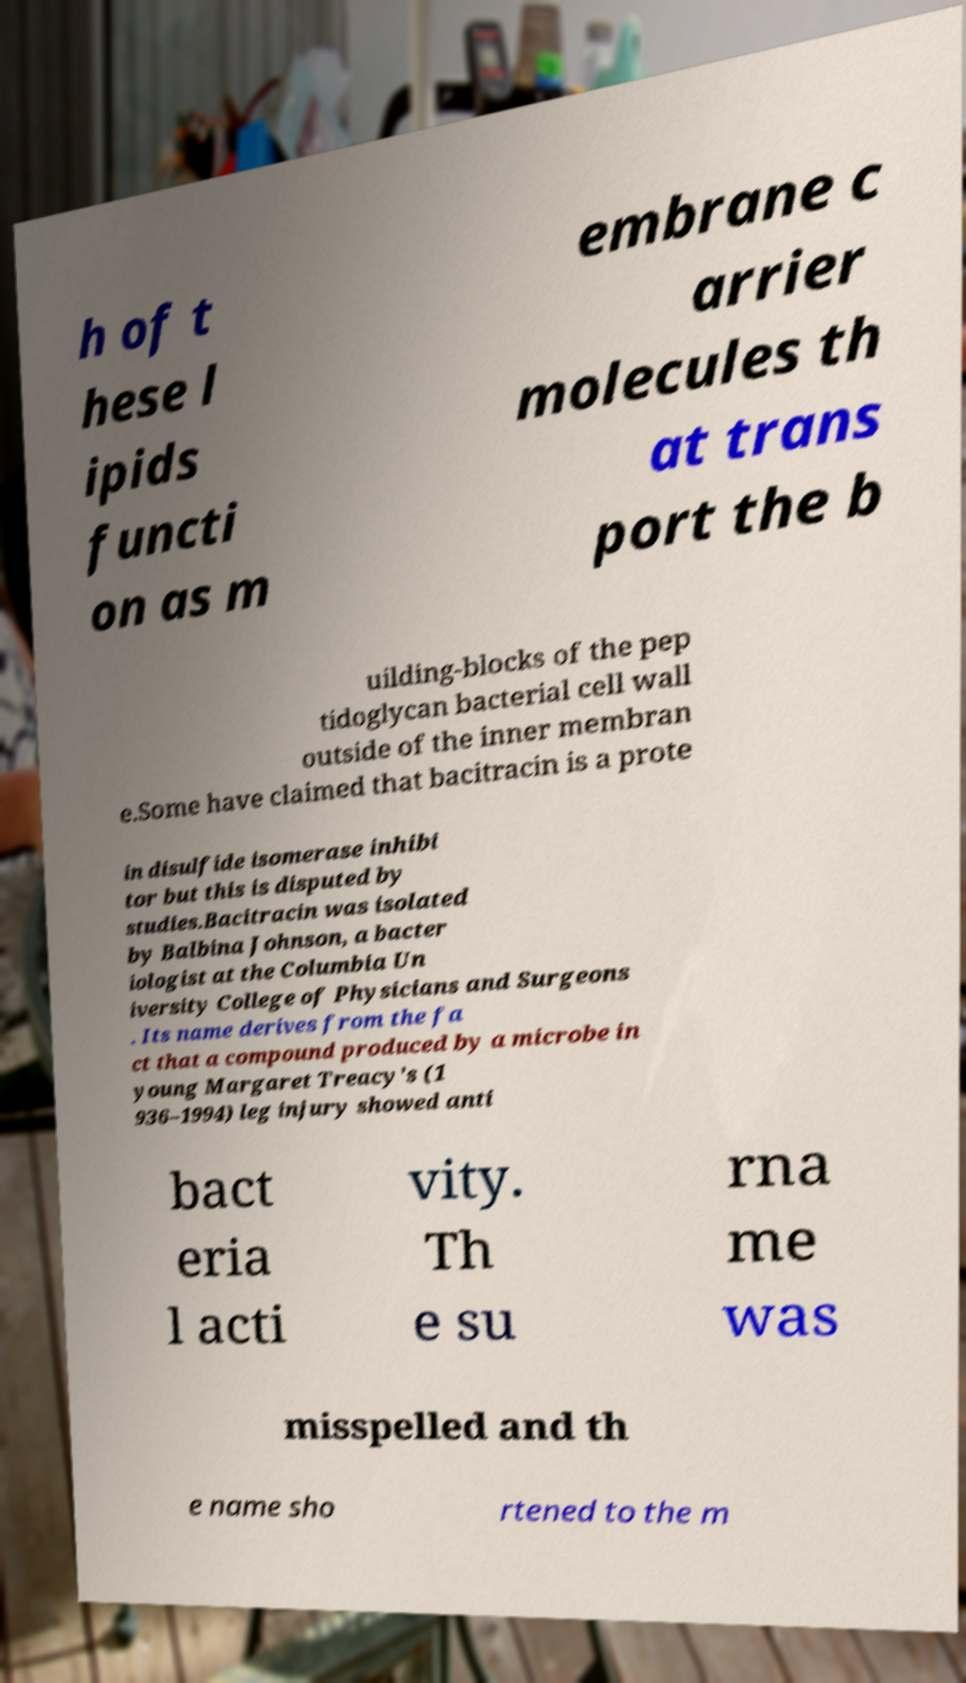I need the written content from this picture converted into text. Can you do that? h of t hese l ipids functi on as m embrane c arrier molecules th at trans port the b uilding-blocks of the pep tidoglycan bacterial cell wall outside of the inner membran e.Some have claimed that bacitracin is a prote in disulfide isomerase inhibi tor but this is disputed by studies.Bacitracin was isolated by Balbina Johnson, a bacter iologist at the Columbia Un iversity College of Physicians and Surgeons . Its name derives from the fa ct that a compound produced by a microbe in young Margaret Treacy's (1 936–1994) leg injury showed anti bact eria l acti vity. Th e su rna me was misspelled and th e name sho rtened to the m 